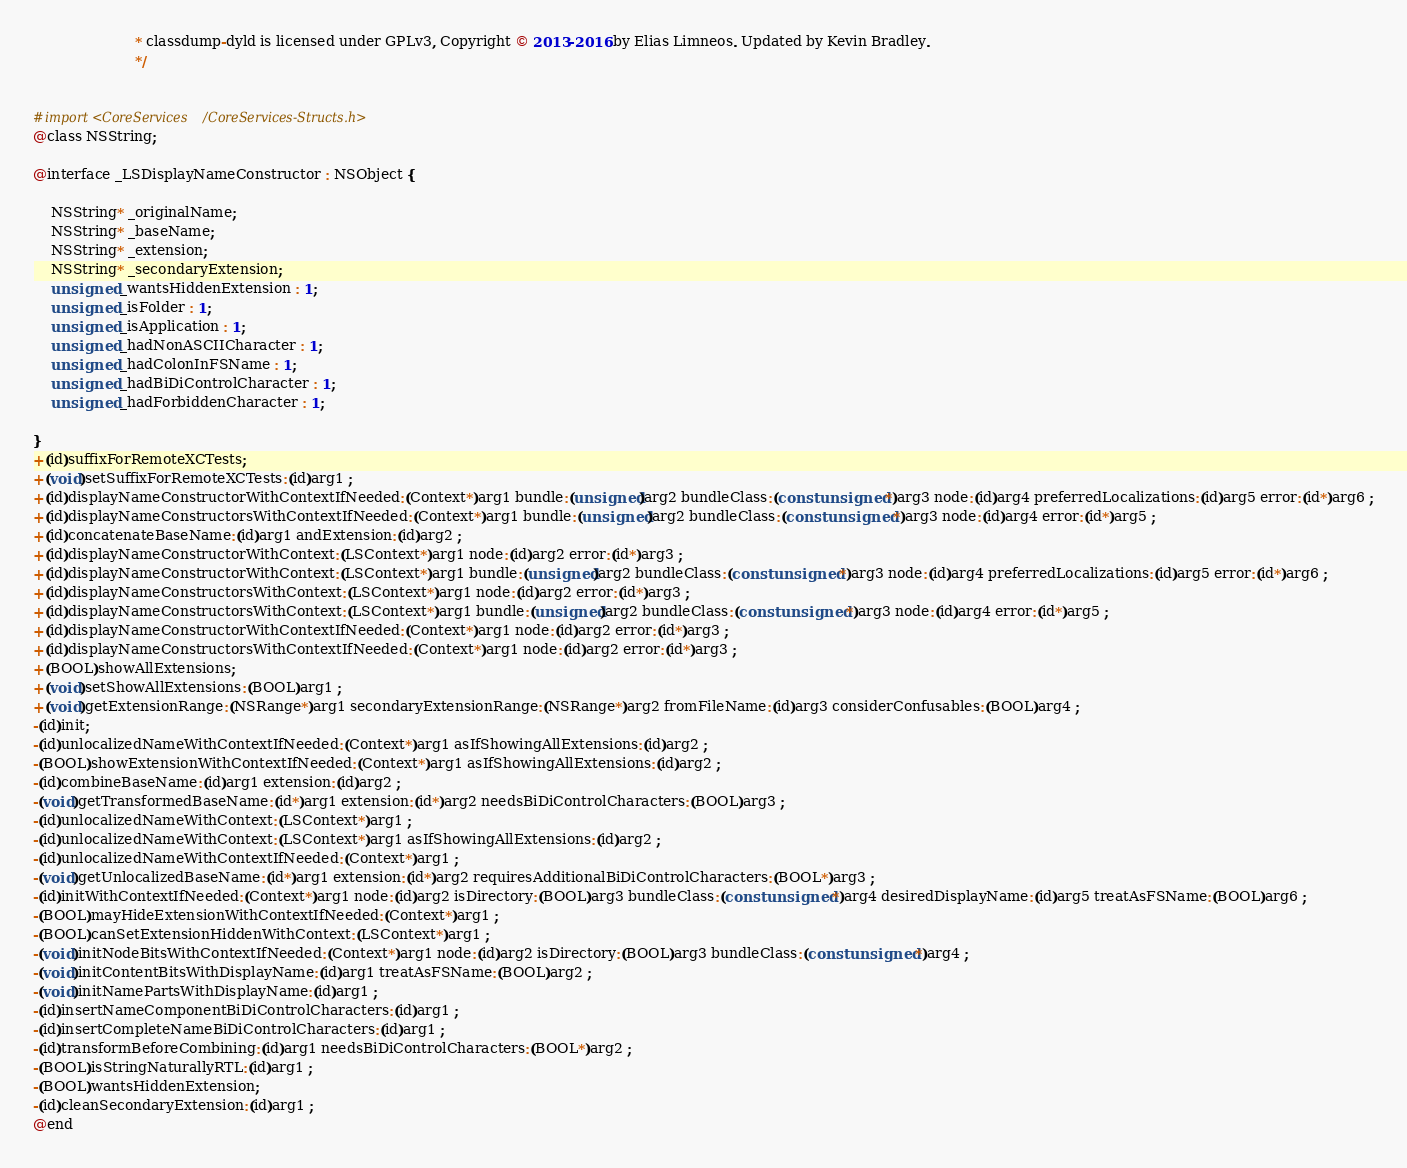<code> <loc_0><loc_0><loc_500><loc_500><_C_>                       * classdump-dyld is licensed under GPLv3, Copyright © 2013-2016 by Elias Limneos. Updated by Kevin Bradley.
                       */


#import <CoreServices/CoreServices-Structs.h>
@class NSString;

@interface _LSDisplayNameConstructor : NSObject {

	NSString* _originalName;
	NSString* _baseName;
	NSString* _extension;
	NSString* _secondaryExtension;
	unsigned _wantsHiddenExtension : 1;
	unsigned _isFolder : 1;
	unsigned _isApplication : 1;
	unsigned _hadNonASCIICharacter : 1;
	unsigned _hadColonInFSName : 1;
	unsigned _hadBiDiControlCharacter : 1;
	unsigned _hadForbiddenCharacter : 1;

}
+(id)suffixForRemoteXCTests;
+(void)setSuffixForRemoteXCTests:(id)arg1 ;
+(id)displayNameConstructorWithContextIfNeeded:(Context*)arg1 bundle:(unsigned)arg2 bundleClass:(const unsigned*)arg3 node:(id)arg4 preferredLocalizations:(id)arg5 error:(id*)arg6 ;
+(id)displayNameConstructorsWithContextIfNeeded:(Context*)arg1 bundle:(unsigned)arg2 bundleClass:(const unsigned*)arg3 node:(id)arg4 error:(id*)arg5 ;
+(id)concatenateBaseName:(id)arg1 andExtension:(id)arg2 ;
+(id)displayNameConstructorWithContext:(LSContext*)arg1 node:(id)arg2 error:(id*)arg3 ;
+(id)displayNameConstructorWithContext:(LSContext*)arg1 bundle:(unsigned)arg2 bundleClass:(const unsigned*)arg3 node:(id)arg4 preferredLocalizations:(id)arg5 error:(id*)arg6 ;
+(id)displayNameConstructorsWithContext:(LSContext*)arg1 node:(id)arg2 error:(id*)arg3 ;
+(id)displayNameConstructorsWithContext:(LSContext*)arg1 bundle:(unsigned)arg2 bundleClass:(const unsigned*)arg3 node:(id)arg4 error:(id*)arg5 ;
+(id)displayNameConstructorWithContextIfNeeded:(Context*)arg1 node:(id)arg2 error:(id*)arg3 ;
+(id)displayNameConstructorsWithContextIfNeeded:(Context*)arg1 node:(id)arg2 error:(id*)arg3 ;
+(BOOL)showAllExtensions;
+(void)setShowAllExtensions:(BOOL)arg1 ;
+(void)getExtensionRange:(NSRange*)arg1 secondaryExtensionRange:(NSRange*)arg2 fromFileName:(id)arg3 considerConfusables:(BOOL)arg4 ;
-(id)init;
-(id)unlocalizedNameWithContextIfNeeded:(Context*)arg1 asIfShowingAllExtensions:(id)arg2 ;
-(BOOL)showExtensionWithContextIfNeeded:(Context*)arg1 asIfShowingAllExtensions:(id)arg2 ;
-(id)combineBaseName:(id)arg1 extension:(id)arg2 ;
-(void)getTransformedBaseName:(id*)arg1 extension:(id*)arg2 needsBiDiControlCharacters:(BOOL)arg3 ;
-(id)unlocalizedNameWithContext:(LSContext*)arg1 ;
-(id)unlocalizedNameWithContext:(LSContext*)arg1 asIfShowingAllExtensions:(id)arg2 ;
-(id)unlocalizedNameWithContextIfNeeded:(Context*)arg1 ;
-(void)getUnlocalizedBaseName:(id*)arg1 extension:(id*)arg2 requiresAdditionalBiDiControlCharacters:(BOOL*)arg3 ;
-(id)initWithContextIfNeeded:(Context*)arg1 node:(id)arg2 isDirectory:(BOOL)arg3 bundleClass:(const unsigned*)arg4 desiredDisplayName:(id)arg5 treatAsFSName:(BOOL)arg6 ;
-(BOOL)mayHideExtensionWithContextIfNeeded:(Context*)arg1 ;
-(BOOL)canSetExtensionHiddenWithContext:(LSContext*)arg1 ;
-(void)initNodeBitsWithContextIfNeeded:(Context*)arg1 node:(id)arg2 isDirectory:(BOOL)arg3 bundleClass:(const unsigned*)arg4 ;
-(void)initContentBitsWithDisplayName:(id)arg1 treatAsFSName:(BOOL)arg2 ;
-(void)initNamePartsWithDisplayName:(id)arg1 ;
-(id)insertNameComponentBiDiControlCharacters:(id)arg1 ;
-(id)insertCompleteNameBiDiControlCharacters:(id)arg1 ;
-(id)transformBeforeCombining:(id)arg1 needsBiDiControlCharacters:(BOOL*)arg2 ;
-(BOOL)isStringNaturallyRTL:(id)arg1 ;
-(BOOL)wantsHiddenExtension;
-(id)cleanSecondaryExtension:(id)arg1 ;
@end

</code> 